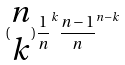<formula> <loc_0><loc_0><loc_500><loc_500>( \begin{matrix} n \\ k \end{matrix} ) \frac { 1 } { n } ^ { k } \frac { n - 1 } { n } ^ { n - k }</formula> 